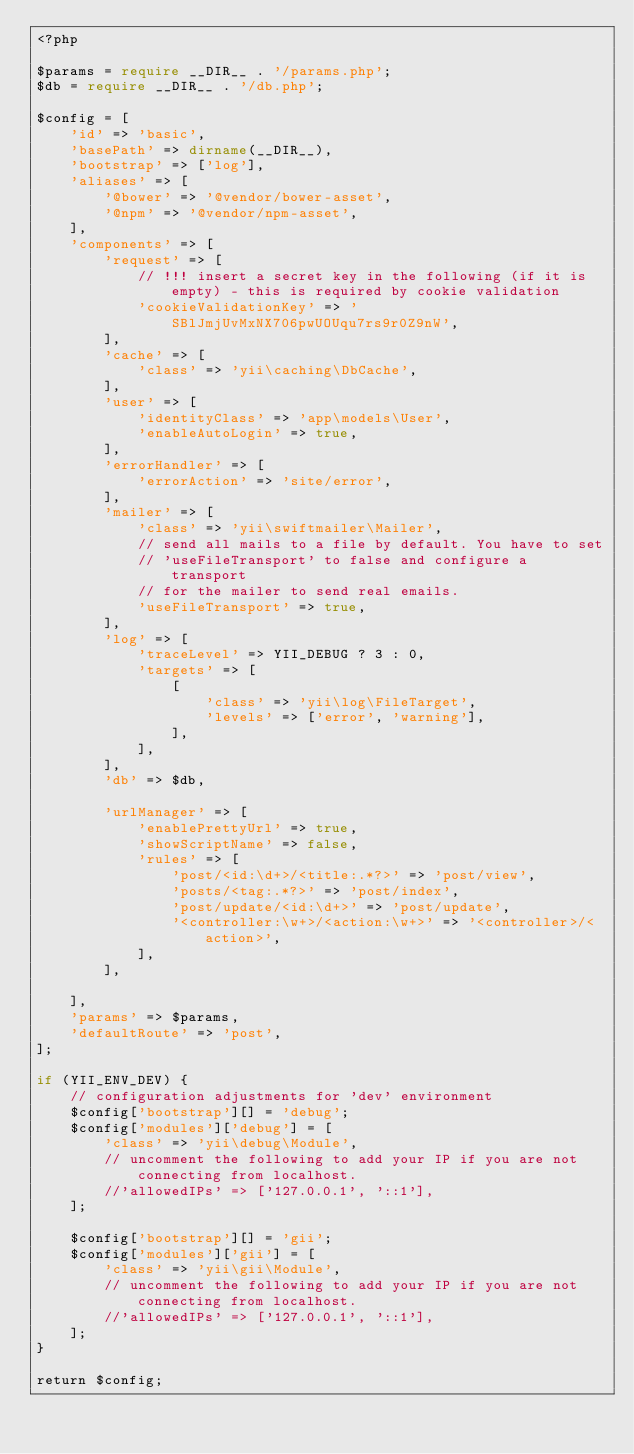<code> <loc_0><loc_0><loc_500><loc_500><_PHP_><?php

$params = require __DIR__ . '/params.php';
$db = require __DIR__ . '/db.php';

$config = [
    'id' => 'basic',
    'basePath' => dirname(__DIR__),
    'bootstrap' => ['log'],
    'aliases' => [
        '@bower' => '@vendor/bower-asset',
        '@npm' => '@vendor/npm-asset',
    ],
    'components' => [
        'request' => [
            // !!! insert a secret key in the following (if it is empty) - this is required by cookie validation
            'cookieValidationKey' => 'SBlJmjUvMxNX706pwUOUqu7rs9r0Z9nW',
        ],
        'cache' => [
            'class' => 'yii\caching\DbCache',
        ],
        'user' => [
            'identityClass' => 'app\models\User',
            'enableAutoLogin' => true,
        ],
        'errorHandler' => [
            'errorAction' => 'site/error',
        ],
        'mailer' => [
            'class' => 'yii\swiftmailer\Mailer',
            // send all mails to a file by default. You have to set
            // 'useFileTransport' to false and configure a transport
            // for the mailer to send real emails.
            'useFileTransport' => true,
        ],
        'log' => [
            'traceLevel' => YII_DEBUG ? 3 : 0,
            'targets' => [
                [
                    'class' => 'yii\log\FileTarget',
                    'levels' => ['error', 'warning'],
                ],
            ],
        ],
        'db' => $db,

        'urlManager' => [
            'enablePrettyUrl' => true,
            'showScriptName' => false,
            'rules' => [
                'post/<id:\d+>/<title:.*?>' => 'post/view',
                'posts/<tag:.*?>' => 'post/index',
                'post/update/<id:\d+>' => 'post/update',
                '<controller:\w+>/<action:\w+>' => '<controller>/<action>',
            ],
        ],

    ],
    'params' => $params,
    'defaultRoute' => 'post',
];

if (YII_ENV_DEV) {
    // configuration adjustments for 'dev' environment
    $config['bootstrap'][] = 'debug';
    $config['modules']['debug'] = [
        'class' => 'yii\debug\Module',
        // uncomment the following to add your IP if you are not connecting from localhost.
        //'allowedIPs' => ['127.0.0.1', '::1'],
    ];

    $config['bootstrap'][] = 'gii';
    $config['modules']['gii'] = [
        'class' => 'yii\gii\Module',
        // uncomment the following to add your IP if you are not connecting from localhost.
        //'allowedIPs' => ['127.0.0.1', '::1'],
    ];
}

return $config;
</code> 